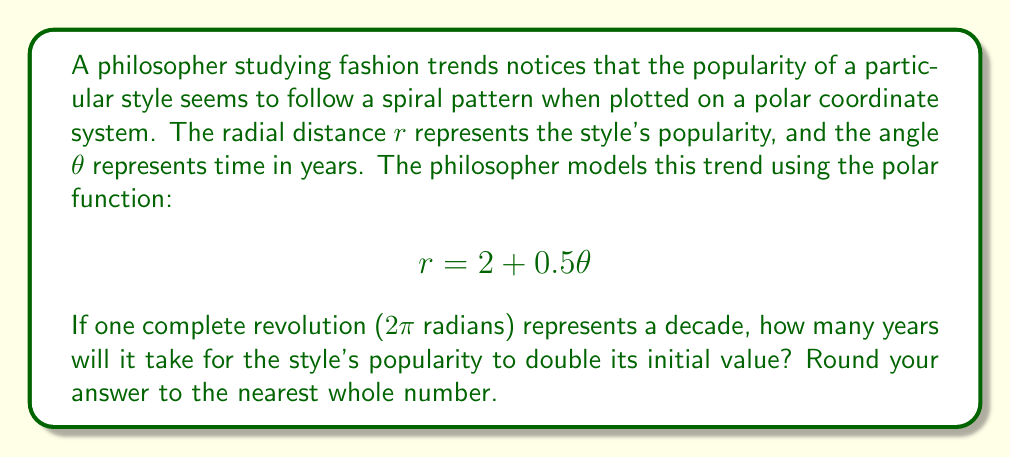Teach me how to tackle this problem. Let's approach this step-by-step:

1) The initial popularity (at $\theta = 0$) is given by:
   $$r_0 = 2 + 0.5(0) = 2$$

2) We want to find when the popularity doubles, so we're looking for:
   $$r = 2r_0 = 2(2) = 4$$

3) We can set up the equation:
   $$4 = 2 + 0.5\theta$$

4) Solve for $\theta$:
   $$2 = 0.5\theta$$
   $$\theta = 4 \text{ radians}$$

5) Now, we need to convert this to years. We're told that $2\pi$ radians represents a decade (10 years).

6) We can set up a proportion:
   $$\frac{2\pi \text{ radians}}{10 \text{ years}} = \frac{4 \text{ radians}}{x \text{ years}}$$

7) Cross multiply and solve for $x$:
   $$2\pi x = 40$$
   $$x = \frac{40}{2\pi} \approx 6.37 \text{ years}$$

8) Rounding to the nearest whole number:
   $$6.37 \text{ years} \approx 6 \text{ years}$$

This aligns with the philosophical concept of cyclical nature in fashion trends, where styles often resurface or evolve over time periods that can be modeled mathematically.
Answer: 6 years 